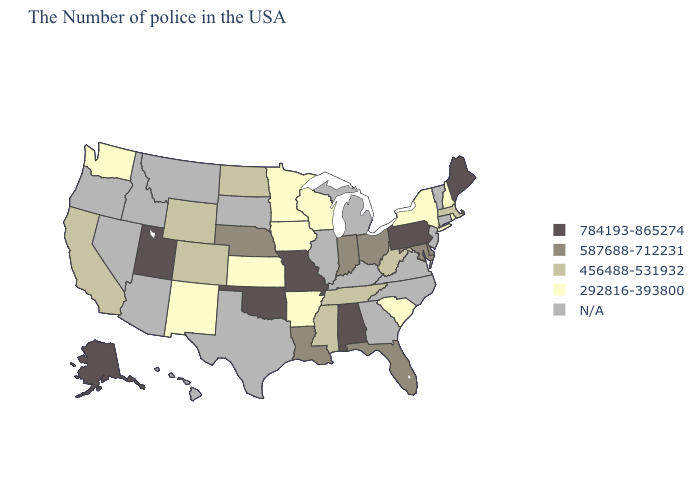Does the map have missing data?
Short answer required. Yes. Name the states that have a value in the range 456488-531932?
Write a very short answer. Massachusetts, West Virginia, Tennessee, Mississippi, North Dakota, Wyoming, Colorado, California. Name the states that have a value in the range 784193-865274?
Be succinct. Maine, Pennsylvania, Alabama, Missouri, Oklahoma, Utah, Alaska. What is the lowest value in states that border Ohio?
Concise answer only. 456488-531932. What is the highest value in states that border Colorado?
Give a very brief answer. 784193-865274. Does Kansas have the highest value in the MidWest?
Be succinct. No. What is the value of Arizona?
Answer briefly. N/A. Name the states that have a value in the range 784193-865274?
Answer briefly. Maine, Pennsylvania, Alabama, Missouri, Oklahoma, Utah, Alaska. What is the lowest value in the USA?
Concise answer only. 292816-393800. Among the states that border Oregon , does California have the lowest value?
Write a very short answer. No. What is the highest value in states that border Georgia?
Be succinct. 784193-865274. What is the value of Colorado?
Keep it brief. 456488-531932. What is the highest value in the Northeast ?
Quick response, please. 784193-865274. Does Oklahoma have the highest value in the South?
Short answer required. Yes. 